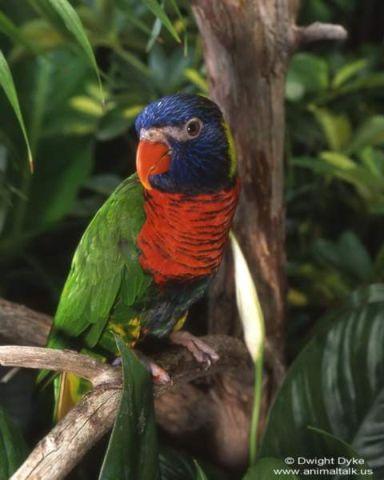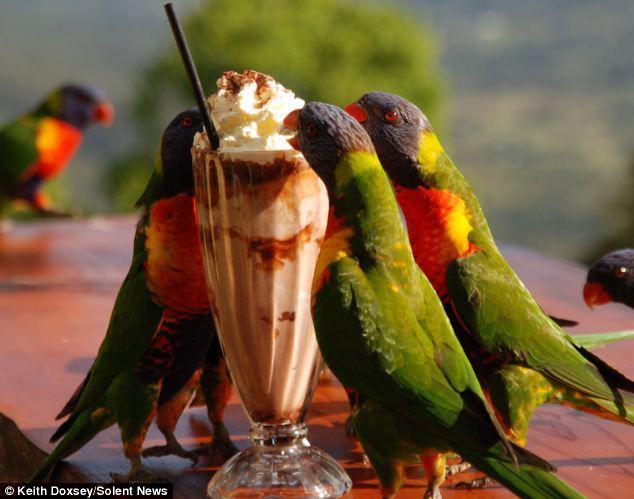The first image is the image on the left, the second image is the image on the right. Given the left and right images, does the statement "there is exactly one bird in the image on the left" hold true? Answer yes or no. Yes. The first image is the image on the left, the second image is the image on the right. Examine the images to the left and right. Is the description "There are at most 4 birds shown." accurate? Answer yes or no. No. 